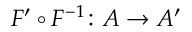Convert formula to latex. <formula><loc_0><loc_0><loc_500><loc_500>F ^ { \prime } \circ F ^ { - 1 } \colon A \to A ^ { \prime }</formula> 